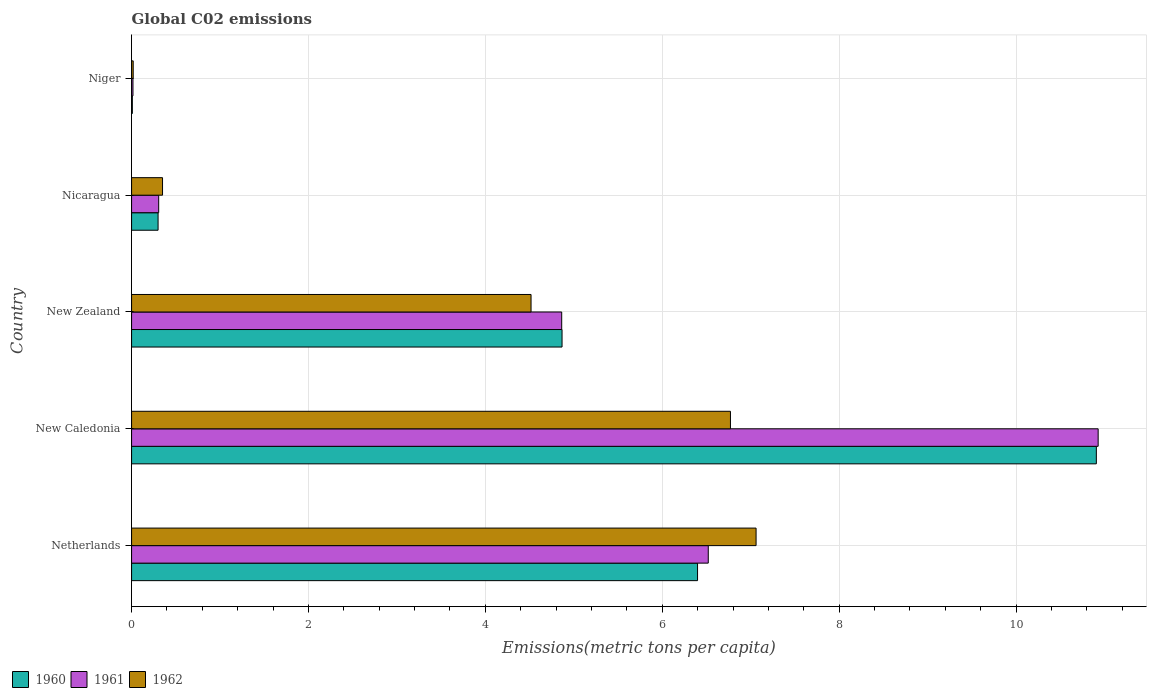How many different coloured bars are there?
Keep it short and to the point. 3. Are the number of bars on each tick of the Y-axis equal?
Your answer should be very brief. Yes. How many bars are there on the 4th tick from the top?
Keep it short and to the point. 3. What is the label of the 1st group of bars from the top?
Your answer should be very brief. Niger. In how many cases, is the number of bars for a given country not equal to the number of legend labels?
Offer a terse response. 0. What is the amount of CO2 emitted in in 1961 in Netherlands?
Keep it short and to the point. 6.52. Across all countries, what is the maximum amount of CO2 emitted in in 1960?
Your answer should be compact. 10.91. Across all countries, what is the minimum amount of CO2 emitted in in 1960?
Give a very brief answer. 0.01. In which country was the amount of CO2 emitted in in 1961 maximum?
Offer a very short reply. New Caledonia. In which country was the amount of CO2 emitted in in 1962 minimum?
Make the answer very short. Niger. What is the total amount of CO2 emitted in in 1961 in the graph?
Keep it short and to the point. 22.63. What is the difference between the amount of CO2 emitted in in 1961 in Netherlands and that in Nicaragua?
Provide a succinct answer. 6.21. What is the difference between the amount of CO2 emitted in in 1960 in Nicaragua and the amount of CO2 emitted in in 1961 in New Caledonia?
Provide a succinct answer. -10.63. What is the average amount of CO2 emitted in in 1961 per country?
Provide a succinct answer. 4.53. What is the difference between the amount of CO2 emitted in in 1960 and amount of CO2 emitted in in 1962 in New Zealand?
Your answer should be compact. 0.35. In how many countries, is the amount of CO2 emitted in in 1960 greater than 0.4 metric tons per capita?
Provide a succinct answer. 3. What is the ratio of the amount of CO2 emitted in in 1961 in Netherlands to that in Niger?
Ensure brevity in your answer.  414.14. Is the amount of CO2 emitted in in 1960 in Netherlands less than that in New Caledonia?
Provide a succinct answer. Yes. Is the difference between the amount of CO2 emitted in in 1960 in New Zealand and Nicaragua greater than the difference between the amount of CO2 emitted in in 1962 in New Zealand and Nicaragua?
Make the answer very short. Yes. What is the difference between the highest and the second highest amount of CO2 emitted in in 1962?
Provide a short and direct response. 0.29. What is the difference between the highest and the lowest amount of CO2 emitted in in 1962?
Provide a short and direct response. 7.04. Is the sum of the amount of CO2 emitted in in 1962 in New Caledonia and Niger greater than the maximum amount of CO2 emitted in in 1960 across all countries?
Make the answer very short. No. Is it the case that in every country, the sum of the amount of CO2 emitted in in 1960 and amount of CO2 emitted in in 1962 is greater than the amount of CO2 emitted in in 1961?
Provide a succinct answer. Yes. Are all the bars in the graph horizontal?
Give a very brief answer. Yes. How many countries are there in the graph?
Your answer should be compact. 5. Does the graph contain any zero values?
Ensure brevity in your answer.  No. How are the legend labels stacked?
Your answer should be compact. Horizontal. What is the title of the graph?
Give a very brief answer. Global C02 emissions. Does "1986" appear as one of the legend labels in the graph?
Your answer should be very brief. No. What is the label or title of the X-axis?
Make the answer very short. Emissions(metric tons per capita). What is the Emissions(metric tons per capita) of 1960 in Netherlands?
Offer a very short reply. 6.4. What is the Emissions(metric tons per capita) of 1961 in Netherlands?
Your response must be concise. 6.52. What is the Emissions(metric tons per capita) of 1962 in Netherlands?
Your answer should be very brief. 7.06. What is the Emissions(metric tons per capita) of 1960 in New Caledonia?
Keep it short and to the point. 10.91. What is the Emissions(metric tons per capita) in 1961 in New Caledonia?
Your response must be concise. 10.93. What is the Emissions(metric tons per capita) in 1962 in New Caledonia?
Provide a succinct answer. 6.77. What is the Emissions(metric tons per capita) in 1960 in New Zealand?
Give a very brief answer. 4.87. What is the Emissions(metric tons per capita) in 1961 in New Zealand?
Provide a succinct answer. 4.86. What is the Emissions(metric tons per capita) in 1962 in New Zealand?
Offer a very short reply. 4.52. What is the Emissions(metric tons per capita) in 1960 in Nicaragua?
Keep it short and to the point. 0.3. What is the Emissions(metric tons per capita) of 1961 in Nicaragua?
Keep it short and to the point. 0.31. What is the Emissions(metric tons per capita) of 1962 in Nicaragua?
Keep it short and to the point. 0.35. What is the Emissions(metric tons per capita) of 1960 in Niger?
Provide a succinct answer. 0.01. What is the Emissions(metric tons per capita) of 1961 in Niger?
Your answer should be very brief. 0.02. What is the Emissions(metric tons per capita) of 1962 in Niger?
Give a very brief answer. 0.02. Across all countries, what is the maximum Emissions(metric tons per capita) of 1960?
Provide a succinct answer. 10.91. Across all countries, what is the maximum Emissions(metric tons per capita) of 1961?
Your response must be concise. 10.93. Across all countries, what is the maximum Emissions(metric tons per capita) of 1962?
Ensure brevity in your answer.  7.06. Across all countries, what is the minimum Emissions(metric tons per capita) of 1960?
Give a very brief answer. 0.01. Across all countries, what is the minimum Emissions(metric tons per capita) in 1961?
Offer a terse response. 0.02. Across all countries, what is the minimum Emissions(metric tons per capita) in 1962?
Ensure brevity in your answer.  0.02. What is the total Emissions(metric tons per capita) of 1960 in the graph?
Offer a very short reply. 22.48. What is the total Emissions(metric tons per capita) of 1961 in the graph?
Offer a very short reply. 22.63. What is the total Emissions(metric tons per capita) in 1962 in the graph?
Keep it short and to the point. 18.72. What is the difference between the Emissions(metric tons per capita) of 1960 in Netherlands and that in New Caledonia?
Keep it short and to the point. -4.51. What is the difference between the Emissions(metric tons per capita) of 1961 in Netherlands and that in New Caledonia?
Your answer should be compact. -4.41. What is the difference between the Emissions(metric tons per capita) of 1962 in Netherlands and that in New Caledonia?
Provide a short and direct response. 0.29. What is the difference between the Emissions(metric tons per capita) of 1960 in Netherlands and that in New Zealand?
Your answer should be very brief. 1.53. What is the difference between the Emissions(metric tons per capita) of 1961 in Netherlands and that in New Zealand?
Offer a terse response. 1.66. What is the difference between the Emissions(metric tons per capita) of 1962 in Netherlands and that in New Zealand?
Your response must be concise. 2.54. What is the difference between the Emissions(metric tons per capita) of 1960 in Netherlands and that in Nicaragua?
Ensure brevity in your answer.  6.1. What is the difference between the Emissions(metric tons per capita) in 1961 in Netherlands and that in Nicaragua?
Offer a terse response. 6.21. What is the difference between the Emissions(metric tons per capita) in 1962 in Netherlands and that in Nicaragua?
Your answer should be compact. 6.71. What is the difference between the Emissions(metric tons per capita) in 1960 in Netherlands and that in Niger?
Make the answer very short. 6.39. What is the difference between the Emissions(metric tons per capita) in 1961 in Netherlands and that in Niger?
Ensure brevity in your answer.  6.5. What is the difference between the Emissions(metric tons per capita) in 1962 in Netherlands and that in Niger?
Your response must be concise. 7.04. What is the difference between the Emissions(metric tons per capita) in 1960 in New Caledonia and that in New Zealand?
Provide a succinct answer. 6.04. What is the difference between the Emissions(metric tons per capita) of 1961 in New Caledonia and that in New Zealand?
Give a very brief answer. 6.07. What is the difference between the Emissions(metric tons per capita) of 1962 in New Caledonia and that in New Zealand?
Ensure brevity in your answer.  2.25. What is the difference between the Emissions(metric tons per capita) of 1960 in New Caledonia and that in Nicaragua?
Your answer should be compact. 10.61. What is the difference between the Emissions(metric tons per capita) of 1961 in New Caledonia and that in Nicaragua?
Provide a succinct answer. 10.62. What is the difference between the Emissions(metric tons per capita) of 1962 in New Caledonia and that in Nicaragua?
Your answer should be very brief. 6.42. What is the difference between the Emissions(metric tons per capita) in 1960 in New Caledonia and that in Niger?
Your answer should be very brief. 10.9. What is the difference between the Emissions(metric tons per capita) of 1961 in New Caledonia and that in Niger?
Offer a terse response. 10.91. What is the difference between the Emissions(metric tons per capita) in 1962 in New Caledonia and that in Niger?
Your response must be concise. 6.75. What is the difference between the Emissions(metric tons per capita) in 1960 in New Zealand and that in Nicaragua?
Your response must be concise. 4.57. What is the difference between the Emissions(metric tons per capita) in 1961 in New Zealand and that in Nicaragua?
Provide a short and direct response. 4.56. What is the difference between the Emissions(metric tons per capita) in 1962 in New Zealand and that in Nicaragua?
Ensure brevity in your answer.  4.17. What is the difference between the Emissions(metric tons per capita) of 1960 in New Zealand and that in Niger?
Make the answer very short. 4.86. What is the difference between the Emissions(metric tons per capita) of 1961 in New Zealand and that in Niger?
Make the answer very short. 4.85. What is the difference between the Emissions(metric tons per capita) of 1962 in New Zealand and that in Niger?
Provide a short and direct response. 4.5. What is the difference between the Emissions(metric tons per capita) in 1960 in Nicaragua and that in Niger?
Give a very brief answer. 0.29. What is the difference between the Emissions(metric tons per capita) of 1961 in Nicaragua and that in Niger?
Make the answer very short. 0.29. What is the difference between the Emissions(metric tons per capita) of 1962 in Nicaragua and that in Niger?
Offer a terse response. 0.33. What is the difference between the Emissions(metric tons per capita) of 1960 in Netherlands and the Emissions(metric tons per capita) of 1961 in New Caledonia?
Your response must be concise. -4.53. What is the difference between the Emissions(metric tons per capita) in 1960 in Netherlands and the Emissions(metric tons per capita) in 1962 in New Caledonia?
Ensure brevity in your answer.  -0.37. What is the difference between the Emissions(metric tons per capita) of 1961 in Netherlands and the Emissions(metric tons per capita) of 1962 in New Caledonia?
Your answer should be compact. -0.25. What is the difference between the Emissions(metric tons per capita) in 1960 in Netherlands and the Emissions(metric tons per capita) in 1961 in New Zealand?
Your response must be concise. 1.54. What is the difference between the Emissions(metric tons per capita) of 1960 in Netherlands and the Emissions(metric tons per capita) of 1962 in New Zealand?
Offer a terse response. 1.88. What is the difference between the Emissions(metric tons per capita) of 1961 in Netherlands and the Emissions(metric tons per capita) of 1962 in New Zealand?
Provide a short and direct response. 2. What is the difference between the Emissions(metric tons per capita) of 1960 in Netherlands and the Emissions(metric tons per capita) of 1961 in Nicaragua?
Provide a succinct answer. 6.09. What is the difference between the Emissions(metric tons per capita) in 1960 in Netherlands and the Emissions(metric tons per capita) in 1962 in Nicaragua?
Keep it short and to the point. 6.05. What is the difference between the Emissions(metric tons per capita) in 1961 in Netherlands and the Emissions(metric tons per capita) in 1962 in Nicaragua?
Your response must be concise. 6.17. What is the difference between the Emissions(metric tons per capita) of 1960 in Netherlands and the Emissions(metric tons per capita) of 1961 in Niger?
Offer a very short reply. 6.38. What is the difference between the Emissions(metric tons per capita) of 1960 in Netherlands and the Emissions(metric tons per capita) of 1962 in Niger?
Offer a very short reply. 6.38. What is the difference between the Emissions(metric tons per capita) in 1961 in Netherlands and the Emissions(metric tons per capita) in 1962 in Niger?
Make the answer very short. 6.5. What is the difference between the Emissions(metric tons per capita) in 1960 in New Caledonia and the Emissions(metric tons per capita) in 1961 in New Zealand?
Ensure brevity in your answer.  6.04. What is the difference between the Emissions(metric tons per capita) in 1960 in New Caledonia and the Emissions(metric tons per capita) in 1962 in New Zealand?
Your answer should be very brief. 6.39. What is the difference between the Emissions(metric tons per capita) of 1961 in New Caledonia and the Emissions(metric tons per capita) of 1962 in New Zealand?
Give a very brief answer. 6.41. What is the difference between the Emissions(metric tons per capita) of 1960 in New Caledonia and the Emissions(metric tons per capita) of 1961 in Nicaragua?
Give a very brief answer. 10.6. What is the difference between the Emissions(metric tons per capita) of 1960 in New Caledonia and the Emissions(metric tons per capita) of 1962 in Nicaragua?
Keep it short and to the point. 10.56. What is the difference between the Emissions(metric tons per capita) of 1961 in New Caledonia and the Emissions(metric tons per capita) of 1962 in Nicaragua?
Give a very brief answer. 10.58. What is the difference between the Emissions(metric tons per capita) of 1960 in New Caledonia and the Emissions(metric tons per capita) of 1961 in Niger?
Give a very brief answer. 10.89. What is the difference between the Emissions(metric tons per capita) in 1960 in New Caledonia and the Emissions(metric tons per capita) in 1962 in Niger?
Make the answer very short. 10.89. What is the difference between the Emissions(metric tons per capita) of 1961 in New Caledonia and the Emissions(metric tons per capita) of 1962 in Niger?
Make the answer very short. 10.91. What is the difference between the Emissions(metric tons per capita) in 1960 in New Zealand and the Emissions(metric tons per capita) in 1961 in Nicaragua?
Ensure brevity in your answer.  4.56. What is the difference between the Emissions(metric tons per capita) of 1960 in New Zealand and the Emissions(metric tons per capita) of 1962 in Nicaragua?
Give a very brief answer. 4.52. What is the difference between the Emissions(metric tons per capita) of 1961 in New Zealand and the Emissions(metric tons per capita) of 1962 in Nicaragua?
Provide a short and direct response. 4.51. What is the difference between the Emissions(metric tons per capita) of 1960 in New Zealand and the Emissions(metric tons per capita) of 1961 in Niger?
Your response must be concise. 4.85. What is the difference between the Emissions(metric tons per capita) in 1960 in New Zealand and the Emissions(metric tons per capita) in 1962 in Niger?
Provide a succinct answer. 4.85. What is the difference between the Emissions(metric tons per capita) of 1961 in New Zealand and the Emissions(metric tons per capita) of 1962 in Niger?
Ensure brevity in your answer.  4.84. What is the difference between the Emissions(metric tons per capita) of 1960 in Nicaragua and the Emissions(metric tons per capita) of 1961 in Niger?
Give a very brief answer. 0.28. What is the difference between the Emissions(metric tons per capita) of 1960 in Nicaragua and the Emissions(metric tons per capita) of 1962 in Niger?
Offer a terse response. 0.28. What is the difference between the Emissions(metric tons per capita) in 1961 in Nicaragua and the Emissions(metric tons per capita) in 1962 in Niger?
Your answer should be compact. 0.29. What is the average Emissions(metric tons per capita) of 1960 per country?
Offer a very short reply. 4.5. What is the average Emissions(metric tons per capita) in 1961 per country?
Make the answer very short. 4.53. What is the average Emissions(metric tons per capita) in 1962 per country?
Provide a short and direct response. 3.74. What is the difference between the Emissions(metric tons per capita) in 1960 and Emissions(metric tons per capita) in 1961 in Netherlands?
Offer a very short reply. -0.12. What is the difference between the Emissions(metric tons per capita) of 1960 and Emissions(metric tons per capita) of 1962 in Netherlands?
Make the answer very short. -0.66. What is the difference between the Emissions(metric tons per capita) of 1961 and Emissions(metric tons per capita) of 1962 in Netherlands?
Offer a terse response. -0.54. What is the difference between the Emissions(metric tons per capita) in 1960 and Emissions(metric tons per capita) in 1961 in New Caledonia?
Keep it short and to the point. -0.02. What is the difference between the Emissions(metric tons per capita) in 1960 and Emissions(metric tons per capita) in 1962 in New Caledonia?
Give a very brief answer. 4.14. What is the difference between the Emissions(metric tons per capita) in 1961 and Emissions(metric tons per capita) in 1962 in New Caledonia?
Your answer should be compact. 4.16. What is the difference between the Emissions(metric tons per capita) of 1960 and Emissions(metric tons per capita) of 1961 in New Zealand?
Keep it short and to the point. 0. What is the difference between the Emissions(metric tons per capita) of 1960 and Emissions(metric tons per capita) of 1962 in New Zealand?
Your answer should be very brief. 0.35. What is the difference between the Emissions(metric tons per capita) of 1961 and Emissions(metric tons per capita) of 1962 in New Zealand?
Offer a very short reply. 0.35. What is the difference between the Emissions(metric tons per capita) in 1960 and Emissions(metric tons per capita) in 1961 in Nicaragua?
Make the answer very short. -0.01. What is the difference between the Emissions(metric tons per capita) of 1960 and Emissions(metric tons per capita) of 1962 in Nicaragua?
Your answer should be compact. -0.05. What is the difference between the Emissions(metric tons per capita) in 1961 and Emissions(metric tons per capita) in 1962 in Nicaragua?
Your answer should be compact. -0.04. What is the difference between the Emissions(metric tons per capita) of 1960 and Emissions(metric tons per capita) of 1961 in Niger?
Offer a very short reply. -0.01. What is the difference between the Emissions(metric tons per capita) of 1960 and Emissions(metric tons per capita) of 1962 in Niger?
Provide a succinct answer. -0.01. What is the difference between the Emissions(metric tons per capita) of 1961 and Emissions(metric tons per capita) of 1962 in Niger?
Give a very brief answer. -0. What is the ratio of the Emissions(metric tons per capita) in 1960 in Netherlands to that in New Caledonia?
Ensure brevity in your answer.  0.59. What is the ratio of the Emissions(metric tons per capita) of 1961 in Netherlands to that in New Caledonia?
Make the answer very short. 0.6. What is the ratio of the Emissions(metric tons per capita) of 1962 in Netherlands to that in New Caledonia?
Give a very brief answer. 1.04. What is the ratio of the Emissions(metric tons per capita) in 1960 in Netherlands to that in New Zealand?
Your response must be concise. 1.31. What is the ratio of the Emissions(metric tons per capita) in 1961 in Netherlands to that in New Zealand?
Offer a terse response. 1.34. What is the ratio of the Emissions(metric tons per capita) of 1962 in Netherlands to that in New Zealand?
Your answer should be compact. 1.56. What is the ratio of the Emissions(metric tons per capita) in 1960 in Netherlands to that in Nicaragua?
Your answer should be very brief. 21.36. What is the ratio of the Emissions(metric tons per capita) in 1961 in Netherlands to that in Nicaragua?
Provide a succinct answer. 21.27. What is the ratio of the Emissions(metric tons per capita) of 1962 in Netherlands to that in Nicaragua?
Ensure brevity in your answer.  20.18. What is the ratio of the Emissions(metric tons per capita) in 1960 in Netherlands to that in Niger?
Give a very brief answer. 740.61. What is the ratio of the Emissions(metric tons per capita) of 1961 in Netherlands to that in Niger?
Give a very brief answer. 414.14. What is the ratio of the Emissions(metric tons per capita) of 1962 in Netherlands to that in Niger?
Provide a short and direct response. 384.74. What is the ratio of the Emissions(metric tons per capita) in 1960 in New Caledonia to that in New Zealand?
Ensure brevity in your answer.  2.24. What is the ratio of the Emissions(metric tons per capita) in 1961 in New Caledonia to that in New Zealand?
Give a very brief answer. 2.25. What is the ratio of the Emissions(metric tons per capita) of 1962 in New Caledonia to that in New Zealand?
Your answer should be compact. 1.5. What is the ratio of the Emissions(metric tons per capita) in 1960 in New Caledonia to that in Nicaragua?
Provide a short and direct response. 36.41. What is the ratio of the Emissions(metric tons per capita) in 1961 in New Caledonia to that in Nicaragua?
Give a very brief answer. 35.65. What is the ratio of the Emissions(metric tons per capita) in 1962 in New Caledonia to that in Nicaragua?
Give a very brief answer. 19.35. What is the ratio of the Emissions(metric tons per capita) in 1960 in New Caledonia to that in Niger?
Ensure brevity in your answer.  1262.46. What is the ratio of the Emissions(metric tons per capita) in 1961 in New Caledonia to that in Niger?
Keep it short and to the point. 694.14. What is the ratio of the Emissions(metric tons per capita) in 1962 in New Caledonia to that in Niger?
Give a very brief answer. 368.96. What is the ratio of the Emissions(metric tons per capita) in 1960 in New Zealand to that in Nicaragua?
Your response must be concise. 16.24. What is the ratio of the Emissions(metric tons per capita) in 1961 in New Zealand to that in Nicaragua?
Offer a terse response. 15.87. What is the ratio of the Emissions(metric tons per capita) of 1962 in New Zealand to that in Nicaragua?
Provide a succinct answer. 12.91. What is the ratio of the Emissions(metric tons per capita) in 1960 in New Zealand to that in Niger?
Offer a terse response. 563.29. What is the ratio of the Emissions(metric tons per capita) of 1961 in New Zealand to that in Niger?
Offer a very short reply. 308.88. What is the ratio of the Emissions(metric tons per capita) in 1962 in New Zealand to that in Niger?
Offer a very short reply. 246.1. What is the ratio of the Emissions(metric tons per capita) in 1960 in Nicaragua to that in Niger?
Offer a very short reply. 34.68. What is the ratio of the Emissions(metric tons per capita) in 1961 in Nicaragua to that in Niger?
Give a very brief answer. 19.47. What is the ratio of the Emissions(metric tons per capita) of 1962 in Nicaragua to that in Niger?
Your answer should be very brief. 19.06. What is the difference between the highest and the second highest Emissions(metric tons per capita) of 1960?
Your response must be concise. 4.51. What is the difference between the highest and the second highest Emissions(metric tons per capita) in 1961?
Offer a very short reply. 4.41. What is the difference between the highest and the second highest Emissions(metric tons per capita) in 1962?
Make the answer very short. 0.29. What is the difference between the highest and the lowest Emissions(metric tons per capita) of 1960?
Offer a terse response. 10.9. What is the difference between the highest and the lowest Emissions(metric tons per capita) of 1961?
Offer a terse response. 10.91. What is the difference between the highest and the lowest Emissions(metric tons per capita) in 1962?
Provide a succinct answer. 7.04. 